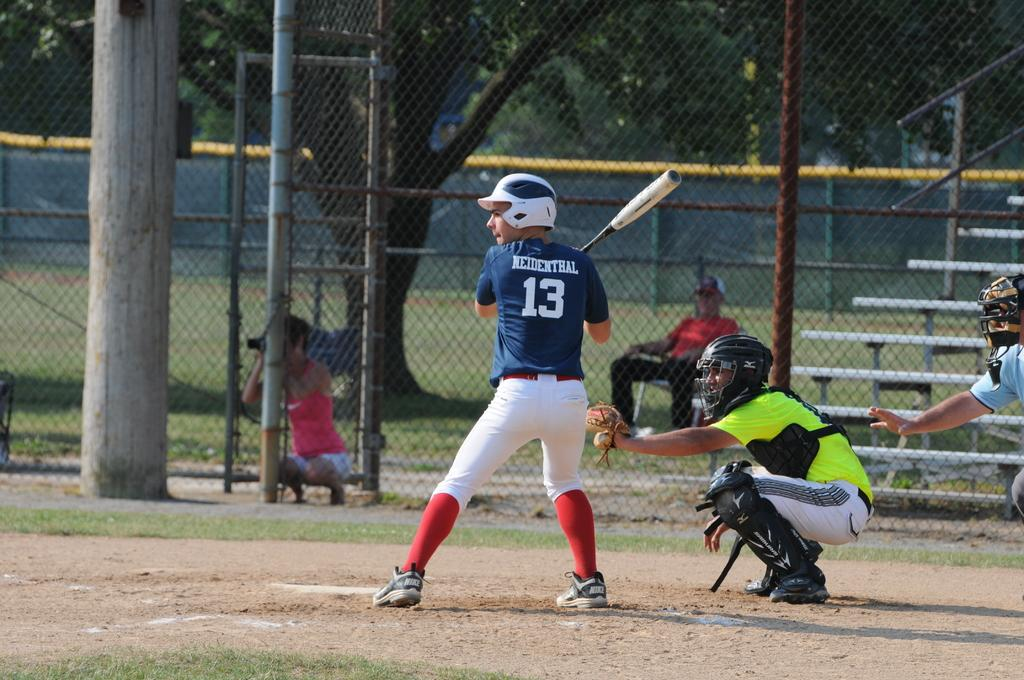<image>
Render a clear and concise summary of the photo. A player named Neidenthal is a bat wearing his blue #13 uniform. 